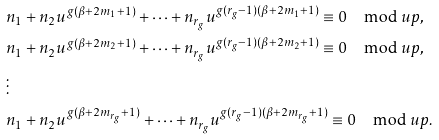Convert formula to latex. <formula><loc_0><loc_0><loc_500><loc_500>& n _ { 1 } + n _ { 2 } u ^ { g ( \beta + 2 m _ { 1 } + 1 ) } + \dots + n _ { r _ { g } } u ^ { g ( r _ { g } - 1 ) ( \beta + 2 m _ { 1 } + 1 ) } \equiv 0 \mod u p , \\ & n _ { 1 } + n _ { 2 } u ^ { g ( \beta + 2 m _ { 2 } + 1 ) } + \dots + n _ { r _ { g } } u ^ { g ( r _ { g } - 1 ) ( \beta + 2 m _ { 2 } + 1 ) } \equiv 0 \mod u p , \\ & \vdots \\ & n _ { 1 } + n _ { 2 } u ^ { g ( \beta + 2 m _ { r _ { g } } + 1 ) } + \dots + n _ { r _ { g } } u ^ { g ( r _ { g } - 1 ) ( \beta + 2 m _ { r _ { g } } + 1 ) } \equiv 0 \mod u p .</formula> 